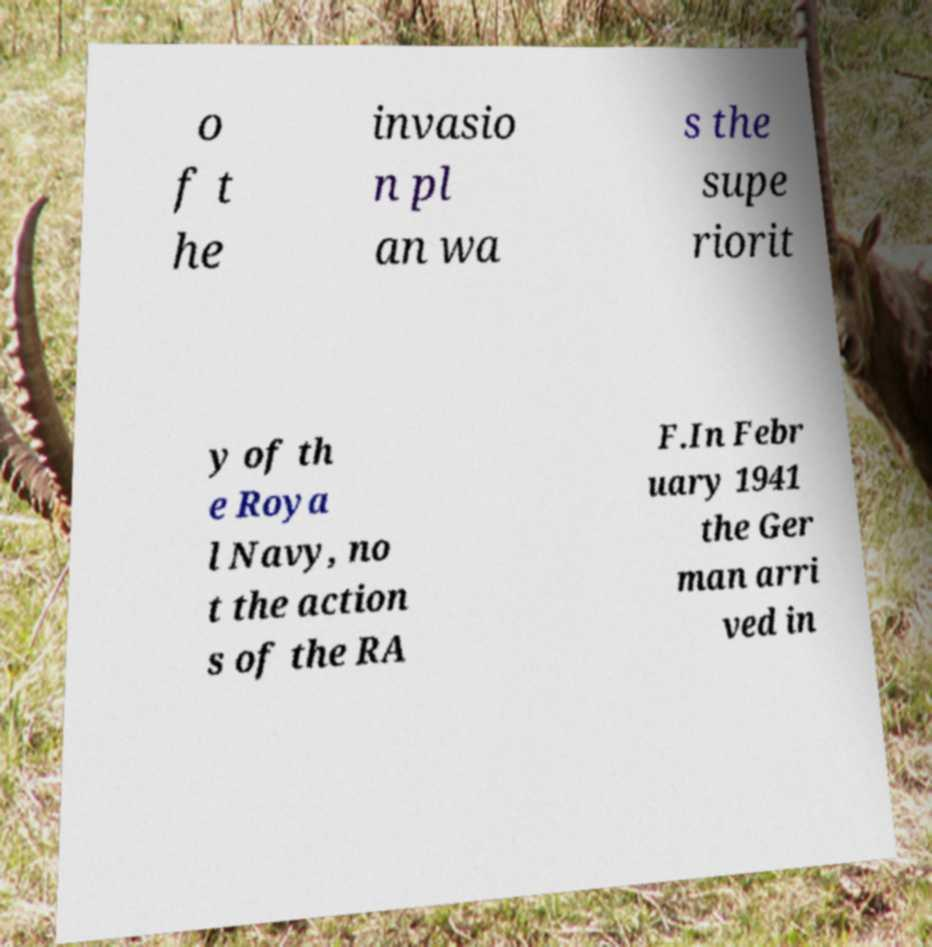Please read and relay the text visible in this image. What does it say? o f t he invasio n pl an wa s the supe riorit y of th e Roya l Navy, no t the action s of the RA F.In Febr uary 1941 the Ger man arri ved in 